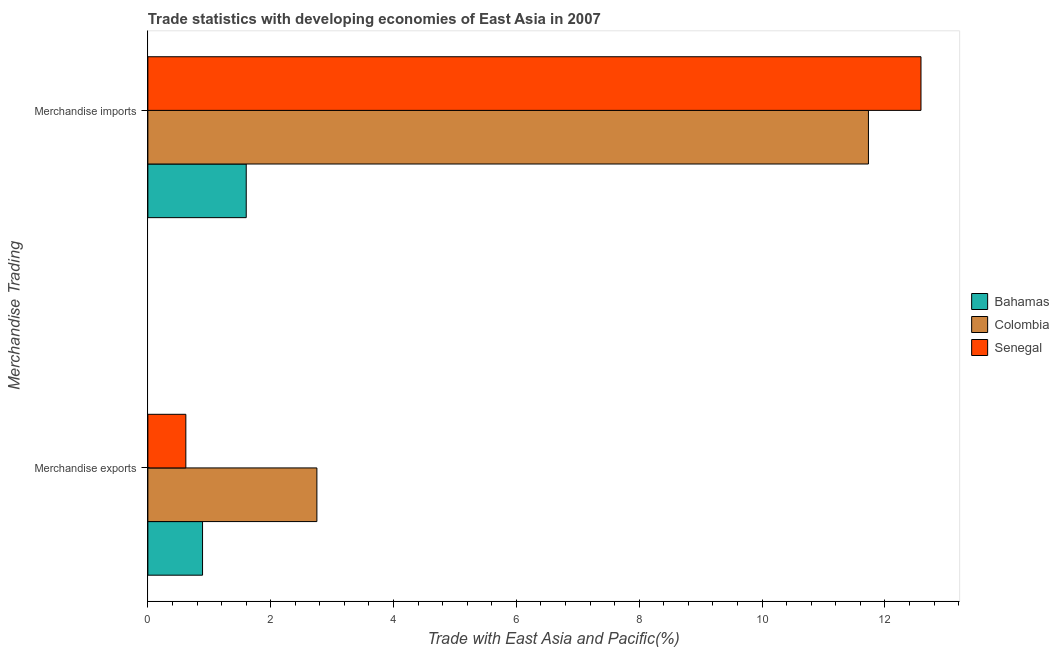How many groups of bars are there?
Your response must be concise. 2. Are the number of bars per tick equal to the number of legend labels?
Your answer should be compact. Yes. What is the label of the 1st group of bars from the top?
Make the answer very short. Merchandise imports. What is the merchandise exports in Senegal?
Provide a short and direct response. 0.62. Across all countries, what is the maximum merchandise exports?
Offer a very short reply. 2.75. Across all countries, what is the minimum merchandise exports?
Ensure brevity in your answer.  0.62. In which country was the merchandise imports maximum?
Your answer should be compact. Senegal. In which country was the merchandise exports minimum?
Offer a very short reply. Senegal. What is the total merchandise imports in the graph?
Ensure brevity in your answer.  25.92. What is the difference between the merchandise imports in Colombia and that in Senegal?
Make the answer very short. -0.86. What is the difference between the merchandise imports in Bahamas and the merchandise exports in Senegal?
Provide a succinct answer. 0.98. What is the average merchandise exports per country?
Make the answer very short. 1.42. What is the difference between the merchandise exports and merchandise imports in Bahamas?
Provide a succinct answer. -0.71. What is the ratio of the merchandise exports in Bahamas to that in Senegal?
Your answer should be compact. 1.44. What does the 2nd bar from the top in Merchandise exports represents?
Provide a short and direct response. Colombia. What does the 3rd bar from the bottom in Merchandise imports represents?
Offer a very short reply. Senegal. How many bars are there?
Provide a short and direct response. 6. What is the difference between two consecutive major ticks on the X-axis?
Your answer should be very brief. 2. Does the graph contain grids?
Keep it short and to the point. No. Where does the legend appear in the graph?
Your answer should be very brief. Center right. How many legend labels are there?
Your answer should be compact. 3. What is the title of the graph?
Keep it short and to the point. Trade statistics with developing economies of East Asia in 2007. What is the label or title of the X-axis?
Give a very brief answer. Trade with East Asia and Pacific(%). What is the label or title of the Y-axis?
Your answer should be very brief. Merchandise Trading. What is the Trade with East Asia and Pacific(%) in Bahamas in Merchandise exports?
Give a very brief answer. 0.89. What is the Trade with East Asia and Pacific(%) in Colombia in Merchandise exports?
Your response must be concise. 2.75. What is the Trade with East Asia and Pacific(%) of Senegal in Merchandise exports?
Ensure brevity in your answer.  0.62. What is the Trade with East Asia and Pacific(%) of Bahamas in Merchandise imports?
Offer a very short reply. 1.6. What is the Trade with East Asia and Pacific(%) of Colombia in Merchandise imports?
Your response must be concise. 11.73. What is the Trade with East Asia and Pacific(%) of Senegal in Merchandise imports?
Your answer should be compact. 12.59. Across all Merchandise Trading, what is the maximum Trade with East Asia and Pacific(%) in Bahamas?
Give a very brief answer. 1.6. Across all Merchandise Trading, what is the maximum Trade with East Asia and Pacific(%) in Colombia?
Keep it short and to the point. 11.73. Across all Merchandise Trading, what is the maximum Trade with East Asia and Pacific(%) in Senegal?
Provide a short and direct response. 12.59. Across all Merchandise Trading, what is the minimum Trade with East Asia and Pacific(%) in Bahamas?
Offer a terse response. 0.89. Across all Merchandise Trading, what is the minimum Trade with East Asia and Pacific(%) of Colombia?
Offer a very short reply. 2.75. Across all Merchandise Trading, what is the minimum Trade with East Asia and Pacific(%) of Senegal?
Your response must be concise. 0.62. What is the total Trade with East Asia and Pacific(%) of Bahamas in the graph?
Your answer should be compact. 2.49. What is the total Trade with East Asia and Pacific(%) in Colombia in the graph?
Your response must be concise. 14.48. What is the total Trade with East Asia and Pacific(%) of Senegal in the graph?
Your answer should be compact. 13.2. What is the difference between the Trade with East Asia and Pacific(%) in Bahamas in Merchandise exports and that in Merchandise imports?
Make the answer very short. -0.71. What is the difference between the Trade with East Asia and Pacific(%) of Colombia in Merchandise exports and that in Merchandise imports?
Keep it short and to the point. -8.98. What is the difference between the Trade with East Asia and Pacific(%) in Senegal in Merchandise exports and that in Merchandise imports?
Offer a very short reply. -11.97. What is the difference between the Trade with East Asia and Pacific(%) of Bahamas in Merchandise exports and the Trade with East Asia and Pacific(%) of Colombia in Merchandise imports?
Your answer should be compact. -10.84. What is the difference between the Trade with East Asia and Pacific(%) in Bahamas in Merchandise exports and the Trade with East Asia and Pacific(%) in Senegal in Merchandise imports?
Your response must be concise. -11.7. What is the difference between the Trade with East Asia and Pacific(%) of Colombia in Merchandise exports and the Trade with East Asia and Pacific(%) of Senegal in Merchandise imports?
Keep it short and to the point. -9.83. What is the average Trade with East Asia and Pacific(%) in Bahamas per Merchandise Trading?
Provide a succinct answer. 1.25. What is the average Trade with East Asia and Pacific(%) in Colombia per Merchandise Trading?
Your answer should be compact. 7.24. What is the average Trade with East Asia and Pacific(%) in Senegal per Merchandise Trading?
Offer a very short reply. 6.6. What is the difference between the Trade with East Asia and Pacific(%) in Bahamas and Trade with East Asia and Pacific(%) in Colombia in Merchandise exports?
Offer a very short reply. -1.86. What is the difference between the Trade with East Asia and Pacific(%) of Bahamas and Trade with East Asia and Pacific(%) of Senegal in Merchandise exports?
Give a very brief answer. 0.27. What is the difference between the Trade with East Asia and Pacific(%) in Colombia and Trade with East Asia and Pacific(%) in Senegal in Merchandise exports?
Provide a short and direct response. 2.13. What is the difference between the Trade with East Asia and Pacific(%) of Bahamas and Trade with East Asia and Pacific(%) of Colombia in Merchandise imports?
Offer a very short reply. -10.13. What is the difference between the Trade with East Asia and Pacific(%) in Bahamas and Trade with East Asia and Pacific(%) in Senegal in Merchandise imports?
Give a very brief answer. -10.99. What is the difference between the Trade with East Asia and Pacific(%) of Colombia and Trade with East Asia and Pacific(%) of Senegal in Merchandise imports?
Keep it short and to the point. -0.86. What is the ratio of the Trade with East Asia and Pacific(%) in Bahamas in Merchandise exports to that in Merchandise imports?
Provide a succinct answer. 0.56. What is the ratio of the Trade with East Asia and Pacific(%) of Colombia in Merchandise exports to that in Merchandise imports?
Offer a very short reply. 0.23. What is the ratio of the Trade with East Asia and Pacific(%) of Senegal in Merchandise exports to that in Merchandise imports?
Provide a short and direct response. 0.05. What is the difference between the highest and the second highest Trade with East Asia and Pacific(%) of Bahamas?
Provide a succinct answer. 0.71. What is the difference between the highest and the second highest Trade with East Asia and Pacific(%) of Colombia?
Your answer should be compact. 8.98. What is the difference between the highest and the second highest Trade with East Asia and Pacific(%) of Senegal?
Your answer should be compact. 11.97. What is the difference between the highest and the lowest Trade with East Asia and Pacific(%) in Bahamas?
Provide a short and direct response. 0.71. What is the difference between the highest and the lowest Trade with East Asia and Pacific(%) in Colombia?
Provide a succinct answer. 8.98. What is the difference between the highest and the lowest Trade with East Asia and Pacific(%) of Senegal?
Ensure brevity in your answer.  11.97. 